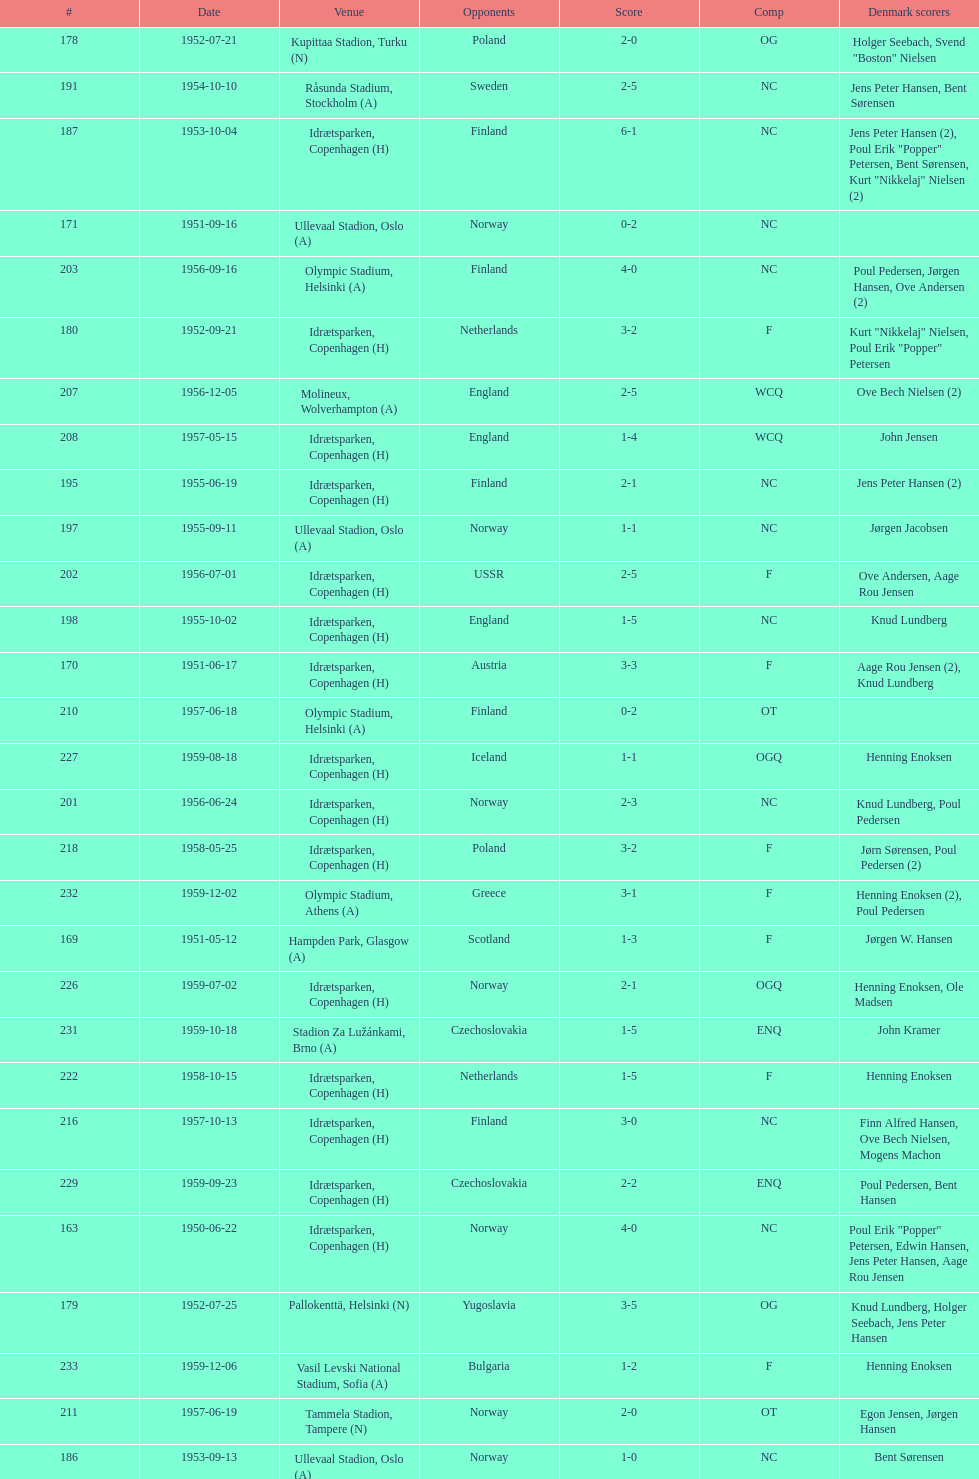Who did they play in the game listed directly above july 25, 1952? Poland. 